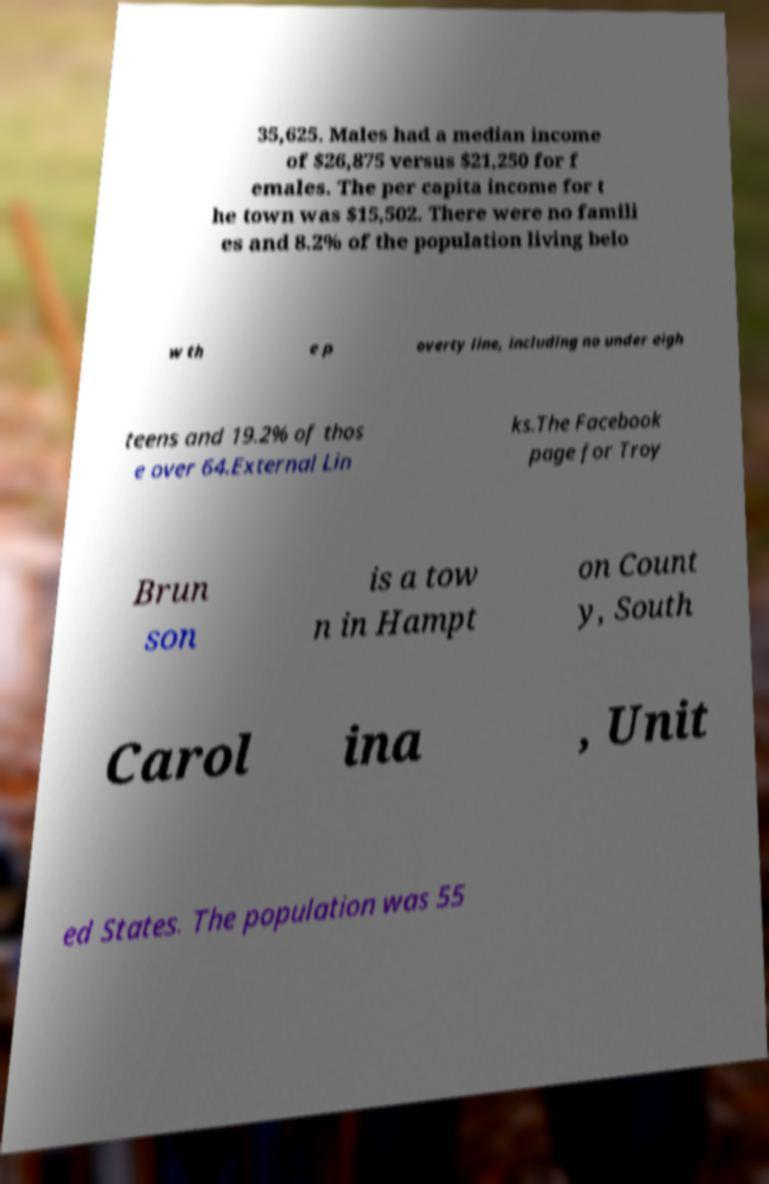Could you assist in decoding the text presented in this image and type it out clearly? 35,625. Males had a median income of $26,875 versus $21,250 for f emales. The per capita income for t he town was $15,502. There were no famili es and 8.2% of the population living belo w th e p overty line, including no under eigh teens and 19.2% of thos e over 64.External Lin ks.The Facebook page for Troy Brun son is a tow n in Hampt on Count y, South Carol ina , Unit ed States. The population was 55 